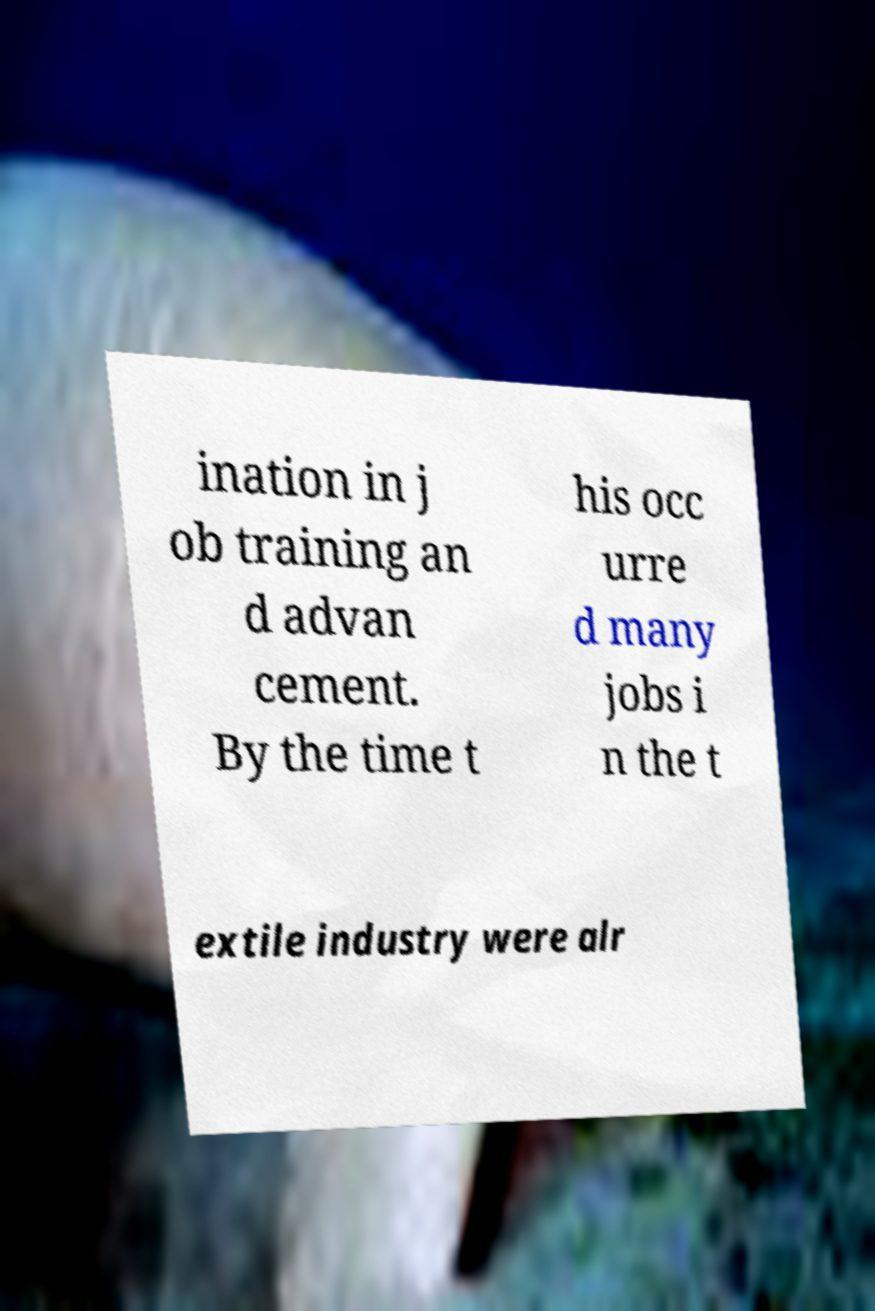Can you read and provide the text displayed in the image?This photo seems to have some interesting text. Can you extract and type it out for me? ination in j ob training an d advan cement. By the time t his occ urre d many jobs i n the t extile industry were alr 